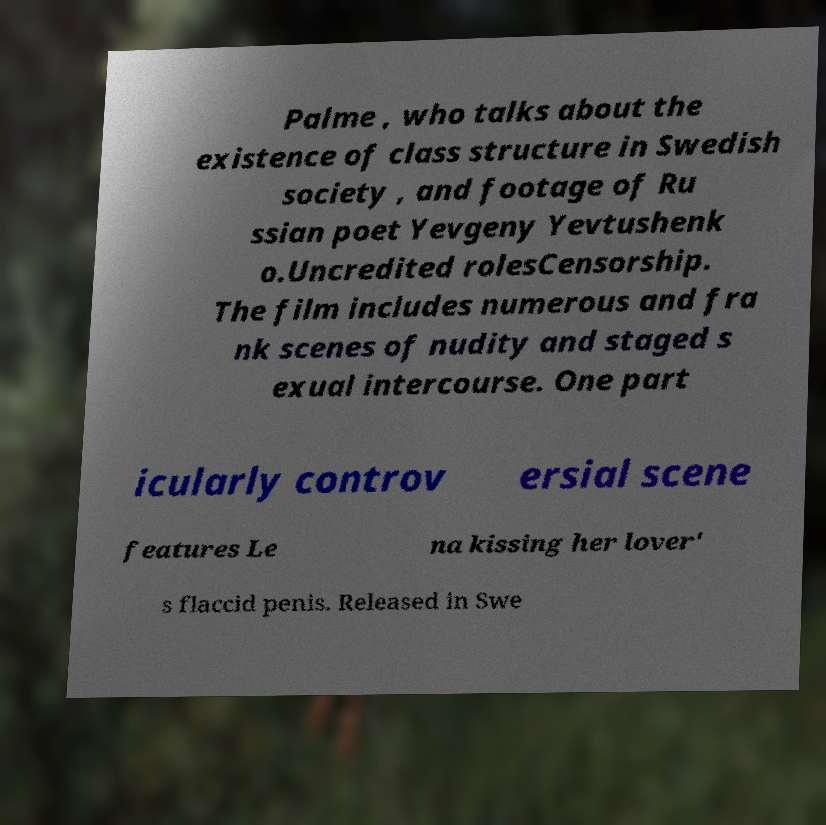What messages or text are displayed in this image? I need them in a readable, typed format. Palme , who talks about the existence of class structure in Swedish society , and footage of Ru ssian poet Yevgeny Yevtushenk o.Uncredited rolesCensorship. The film includes numerous and fra nk scenes of nudity and staged s exual intercourse. One part icularly controv ersial scene features Le na kissing her lover' s flaccid penis. Released in Swe 